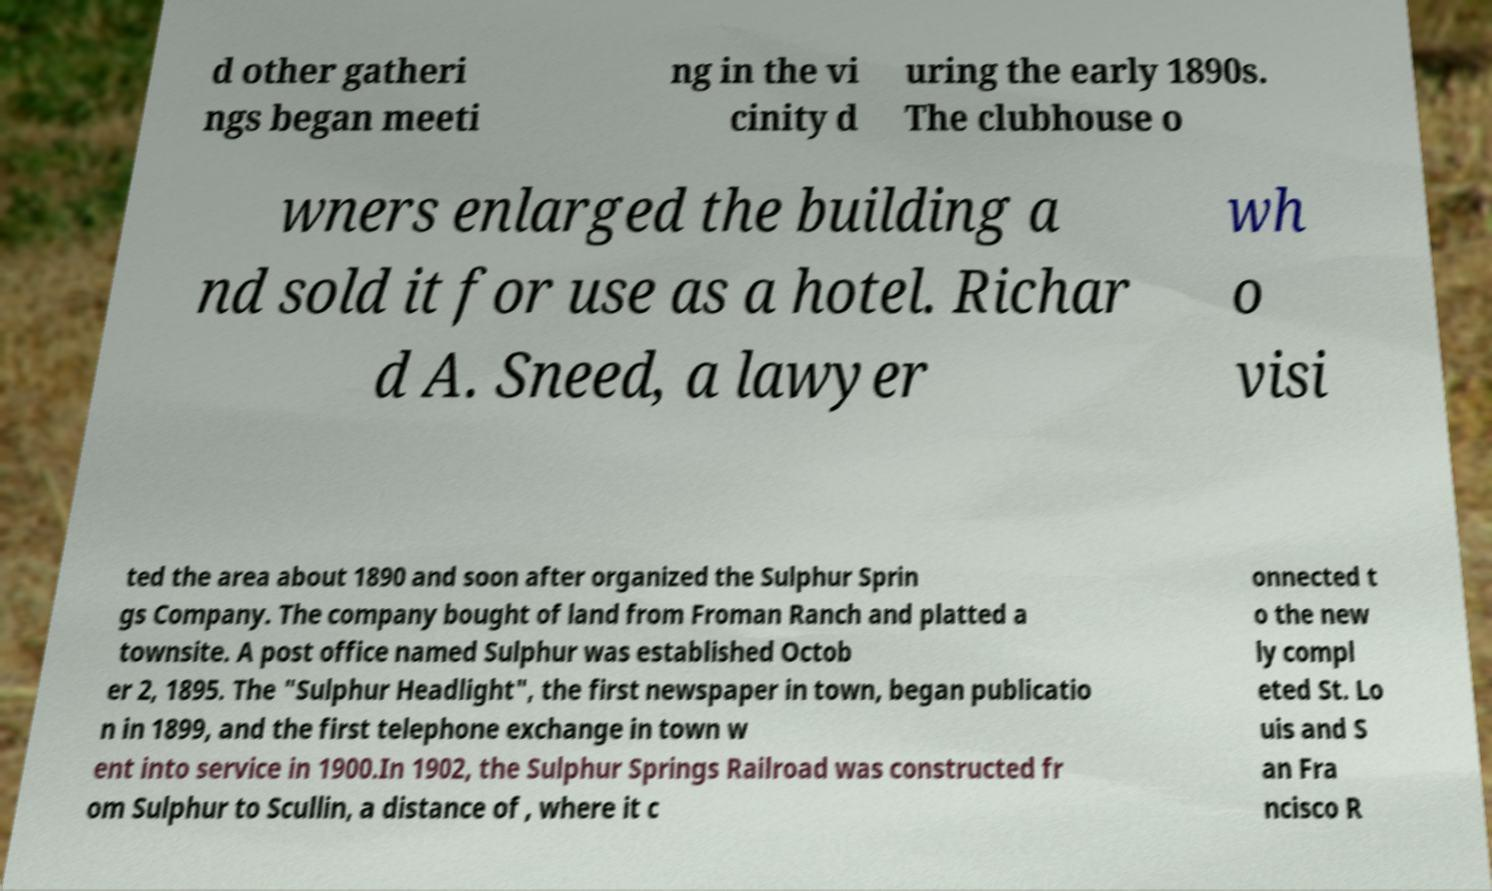Could you assist in decoding the text presented in this image and type it out clearly? d other gatheri ngs began meeti ng in the vi cinity d uring the early 1890s. The clubhouse o wners enlarged the building a nd sold it for use as a hotel. Richar d A. Sneed, a lawyer wh o visi ted the area about 1890 and soon after organized the Sulphur Sprin gs Company. The company bought of land from Froman Ranch and platted a townsite. A post office named Sulphur was established Octob er 2, 1895. The "Sulphur Headlight", the first newspaper in town, began publicatio n in 1899, and the first telephone exchange in town w ent into service in 1900.In 1902, the Sulphur Springs Railroad was constructed fr om Sulphur to Scullin, a distance of , where it c onnected t o the new ly compl eted St. Lo uis and S an Fra ncisco R 